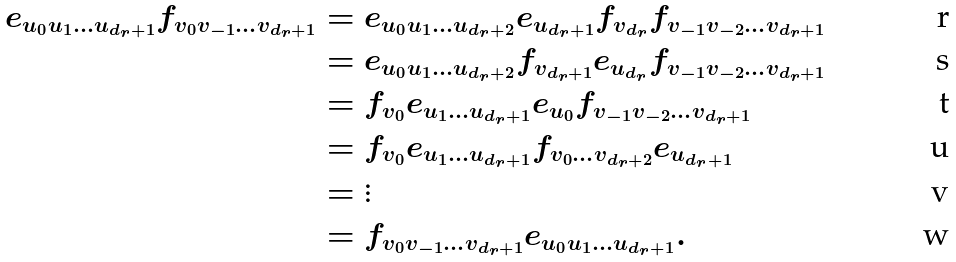<formula> <loc_0><loc_0><loc_500><loc_500>e _ { u _ { 0 } u _ { 1 } \dots u _ { d _ { r } + 1 } } f _ { v _ { 0 } v _ { - 1 } \dots v _ { d _ { r } + 1 } } & = e _ { u _ { 0 } u _ { 1 } \dots u _ { d _ { r } + 2 } } e _ { u _ { d _ { r } + 1 } } f _ { v _ { d _ { r } } } f _ { v _ { - 1 } v _ { - 2 } \dots v _ { d _ { r } + 1 } } \\ & = e _ { u _ { 0 } u _ { 1 } \dots u _ { d _ { r } + 2 } } f _ { v _ { d _ { r } + 1 } } e _ { u _ { d _ { r } } } f _ { v _ { - 1 } v _ { - 2 } \dots v _ { d _ { r } + 1 } } \\ & = f _ { v _ { 0 } } e _ { u _ { 1 } \dots u _ { d _ { r } + 1 } } e _ { u _ { 0 } } f _ { v _ { - 1 } v _ { - 2 } \dots v _ { d _ { r } + 1 } } \\ & = f _ { v _ { 0 } } e _ { u _ { 1 } \dots u _ { d _ { r } + 1 } } f _ { v _ { 0 } \dots v _ { d _ { r } + 2 } } e _ { u _ { d _ { r } + 1 } } \\ & = \vdots \\ & = f _ { v _ { 0 } v _ { - 1 } \dots v _ { d _ { r } + 1 } } e _ { u _ { 0 } u _ { 1 } \dots u _ { d _ { r } + 1 } } .</formula> 